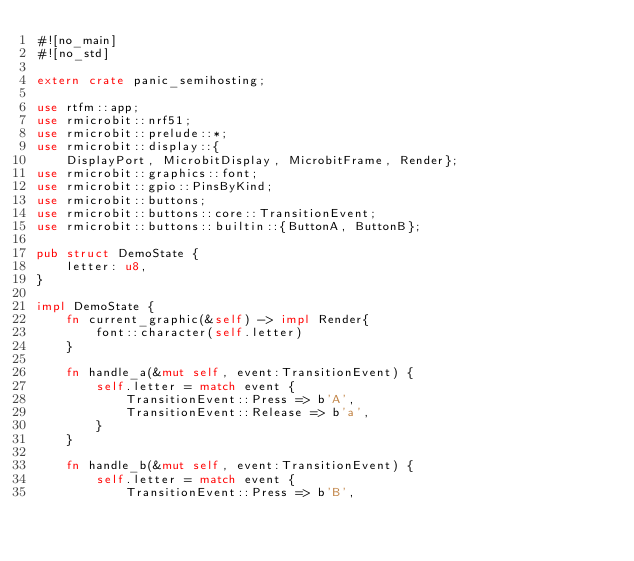<code> <loc_0><loc_0><loc_500><loc_500><_Rust_>#![no_main]
#![no_std]

extern crate panic_semihosting;

use rtfm::app;
use rmicrobit::nrf51;
use rmicrobit::prelude::*;
use rmicrobit::display::{
    DisplayPort, MicrobitDisplay, MicrobitFrame, Render};
use rmicrobit::graphics::font;
use rmicrobit::gpio::PinsByKind;
use rmicrobit::buttons;
use rmicrobit::buttons::core::TransitionEvent;
use rmicrobit::buttons::builtin::{ButtonA, ButtonB};

pub struct DemoState {
    letter: u8,
}

impl DemoState {
    fn current_graphic(&self) -> impl Render{
        font::character(self.letter)
    }

    fn handle_a(&mut self, event:TransitionEvent) {
        self.letter = match event {
            TransitionEvent::Press => b'A',
            TransitionEvent::Release => b'a',
        }
    }

    fn handle_b(&mut self, event:TransitionEvent) {
        self.letter = match event {
            TransitionEvent::Press => b'B',</code> 